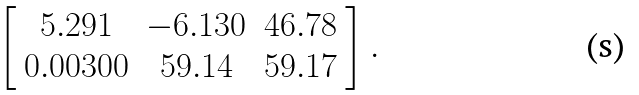Convert formula to latex. <formula><loc_0><loc_0><loc_500><loc_500>\left [ { \begin{array} { c c c } { 5 . 2 9 1 } & { - 6 . 1 3 0 } & { 4 6 . 7 8 } \\ { 0 . 0 0 3 0 0 } & { 5 9 . 1 4 } & { 5 9 . 1 7 } \end{array} } \right ] .</formula> 